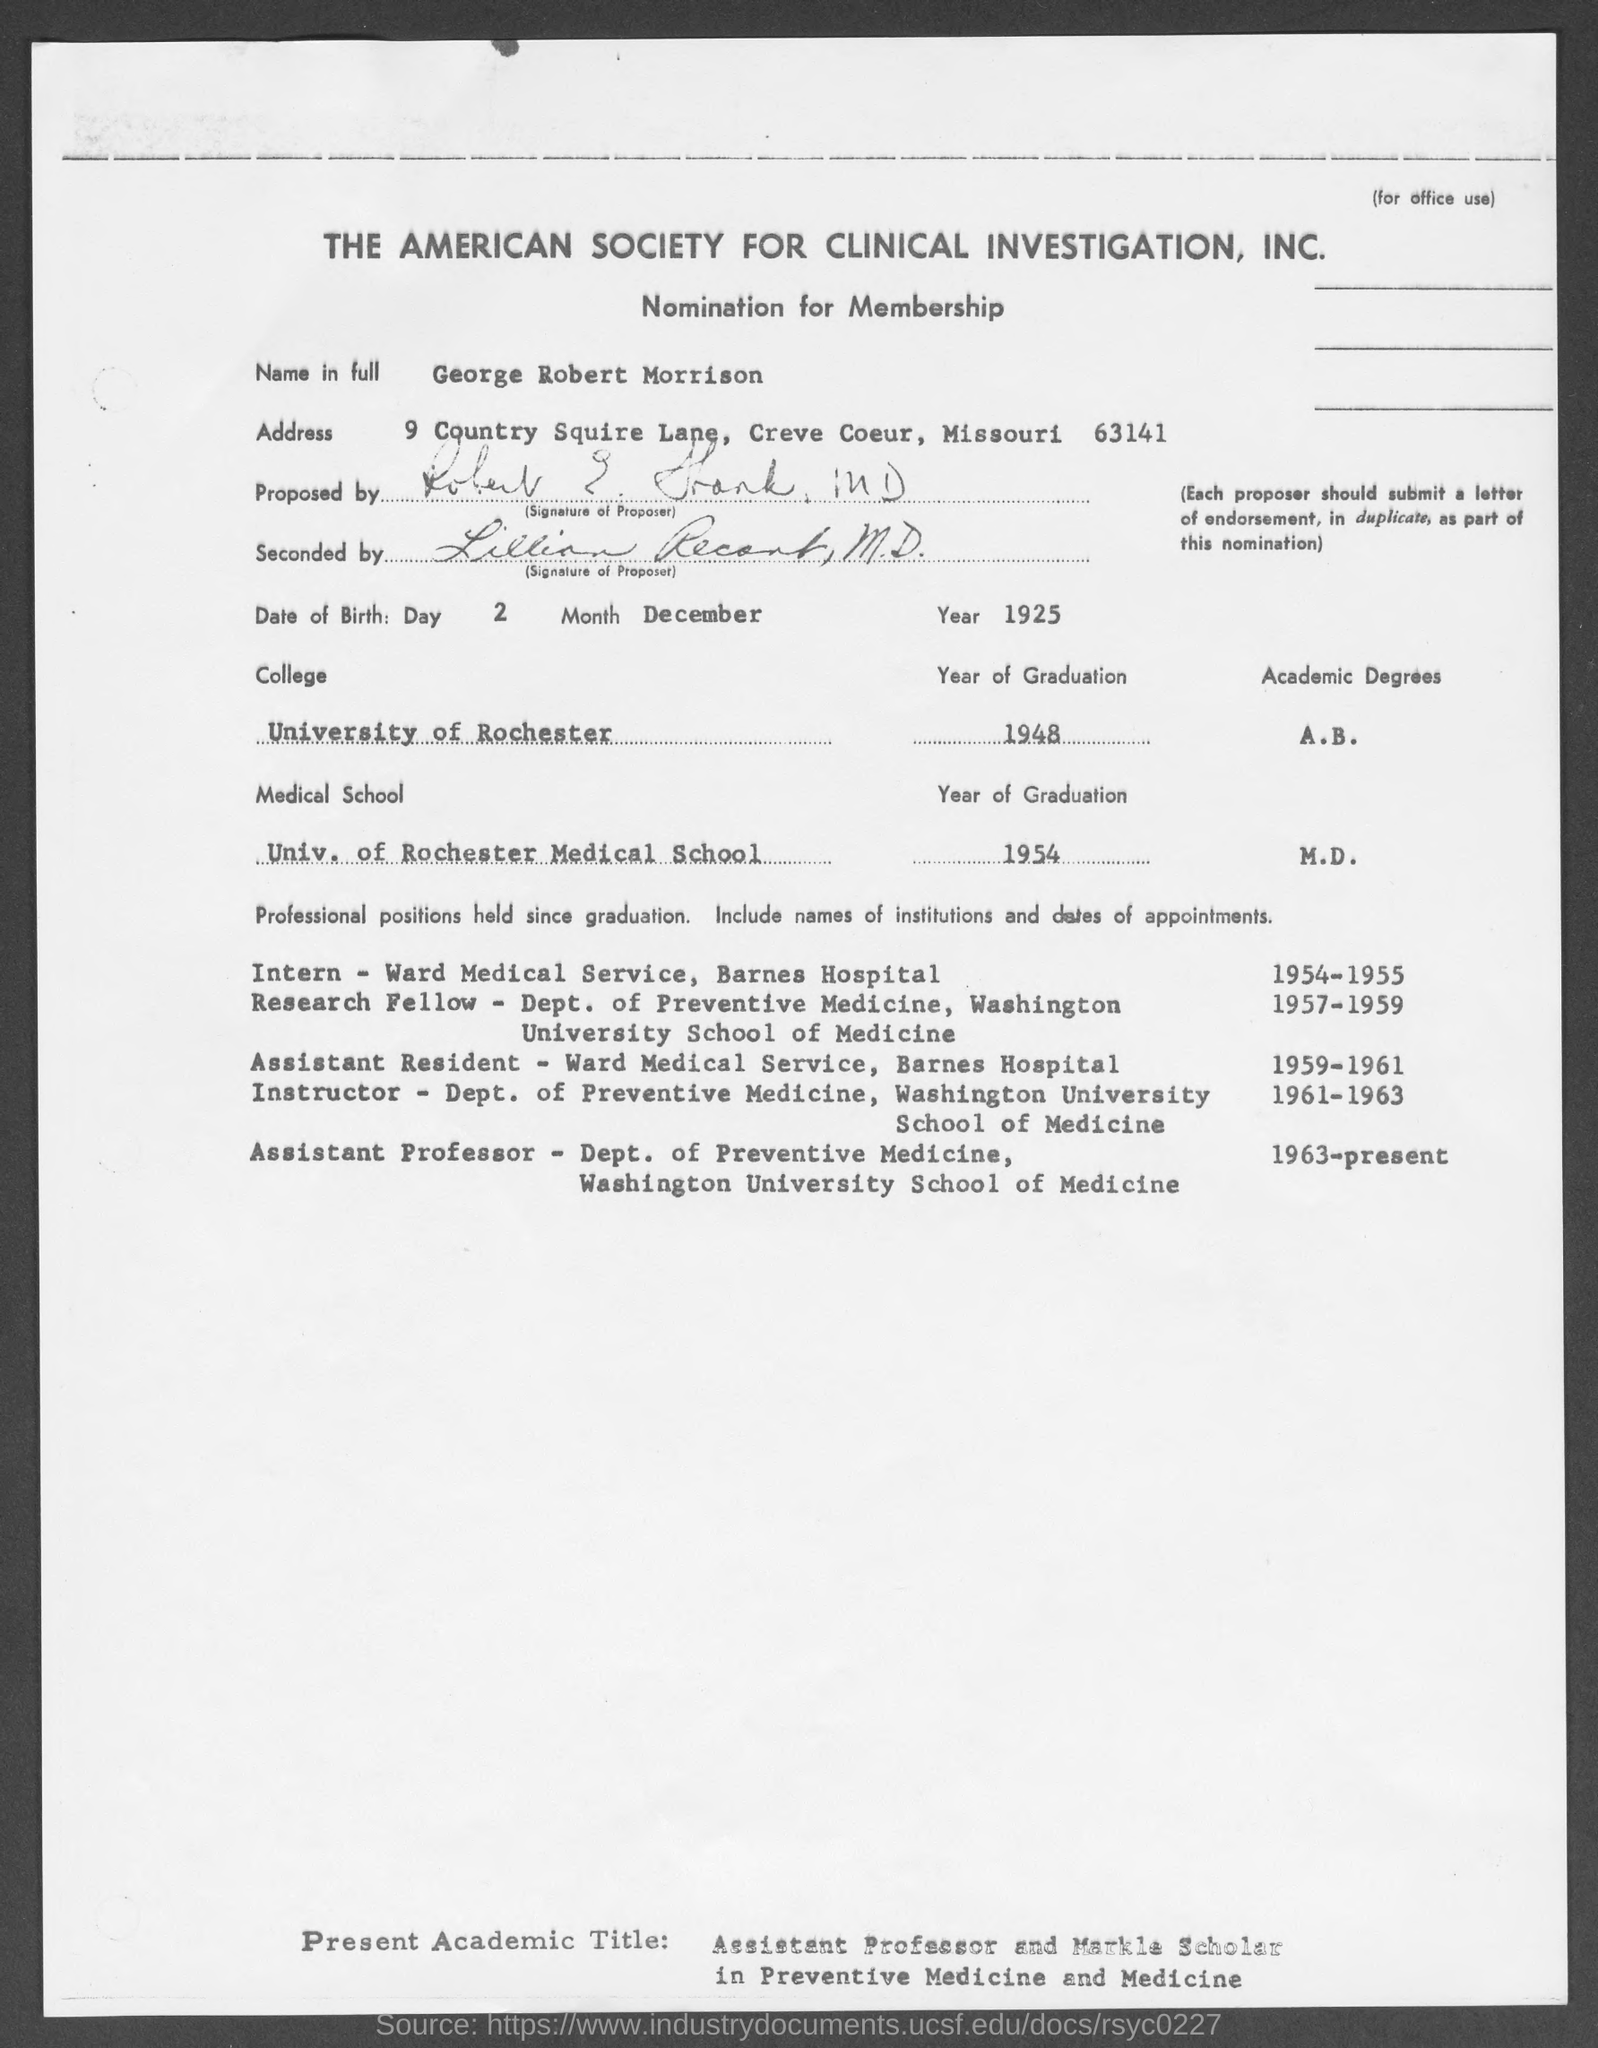Who is willing to get nominated for membership?
Provide a short and direct response. GEORGE ROBERT MORRISON. In which year did George finish his graduation from University of Rochester?
Offer a terse response. 1948. In which year did George finish his graduation from University of Rochester Medical School?
Provide a short and direct response. 1954. 